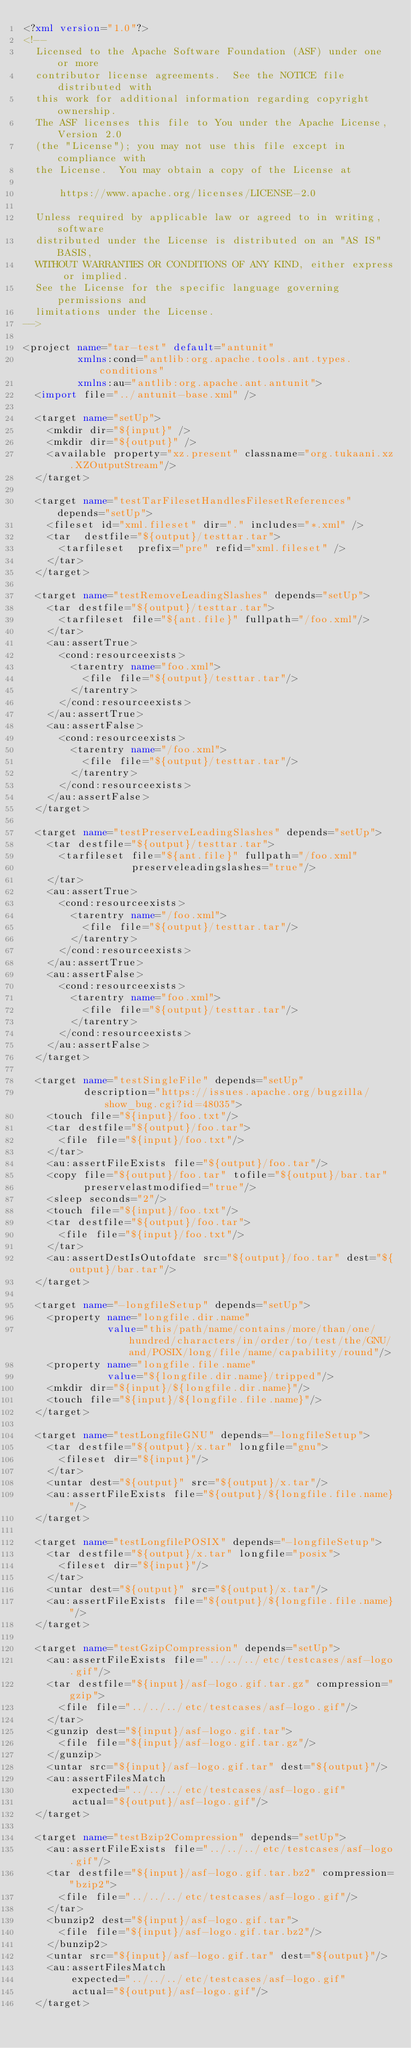Convert code to text. <code><loc_0><loc_0><loc_500><loc_500><_XML_><?xml version="1.0"?>
<!--
  Licensed to the Apache Software Foundation (ASF) under one or more
  contributor license agreements.  See the NOTICE file distributed with
  this work for additional information regarding copyright ownership.
  The ASF licenses this file to You under the Apache License, Version 2.0
  (the "License"); you may not use this file except in compliance with
  the License.  You may obtain a copy of the License at

      https://www.apache.org/licenses/LICENSE-2.0

  Unless required by applicable law or agreed to in writing, software
  distributed under the License is distributed on an "AS IS" BASIS,
  WITHOUT WARRANTIES OR CONDITIONS OF ANY KIND, either express or implied.
  See the License for the specific language governing permissions and
  limitations under the License.
-->

<project name="tar-test" default="antunit"
         xmlns:cond="antlib:org.apache.tools.ant.types.conditions"
         xmlns:au="antlib:org.apache.ant.antunit">
  <import file="../antunit-base.xml" />

  <target name="setUp">
    <mkdir dir="${input}" />
    <mkdir dir="${output}" />
    <available property="xz.present" classname="org.tukaani.xz.XZOutputStream"/>
  </target>

  <target name="testTarFilesetHandlesFilesetReferences" depends="setUp">
    <fileset id="xml.fileset" dir="." includes="*.xml" />
    <tar  destfile="${output}/testtar.tar">
      <tarfileset  prefix="pre" refid="xml.fileset" />
    </tar>
  </target>

  <target name="testRemoveLeadingSlashes" depends="setUp">
    <tar destfile="${output}/testtar.tar">
      <tarfileset file="${ant.file}" fullpath="/foo.xml"/>
    </tar>
    <au:assertTrue>
      <cond:resourceexists>
        <tarentry name="foo.xml">
          <file file="${output}/testtar.tar"/>
        </tarentry>
      </cond:resourceexists>
    </au:assertTrue>
    <au:assertFalse>
      <cond:resourceexists>
        <tarentry name="/foo.xml">
          <file file="${output}/testtar.tar"/>
        </tarentry>
      </cond:resourceexists>
    </au:assertFalse>
  </target>

  <target name="testPreserveLeadingSlashes" depends="setUp">
    <tar destfile="${output}/testtar.tar">
      <tarfileset file="${ant.file}" fullpath="/foo.xml"
                  preserveleadingslashes="true"/>
    </tar>
    <au:assertTrue>
      <cond:resourceexists>
        <tarentry name="/foo.xml">
          <file file="${output}/testtar.tar"/>
        </tarentry>
      </cond:resourceexists>
    </au:assertTrue>
    <au:assertFalse>
      <cond:resourceexists>
        <tarentry name="foo.xml">
          <file file="${output}/testtar.tar"/>
        </tarentry>
      </cond:resourceexists>
    </au:assertFalse>
  </target>

  <target name="testSingleFile" depends="setUp"
          description="https://issues.apache.org/bugzilla/show_bug.cgi?id=48035">
    <touch file="${input}/foo.txt"/>
    <tar destfile="${output}/foo.tar">
      <file file="${input}/foo.txt"/>
    </tar>
    <au:assertFileExists file="${output}/foo.tar"/>
    <copy file="${output}/foo.tar" tofile="${output}/bar.tar"
          preservelastmodified="true"/>
    <sleep seconds="2"/>
    <touch file="${input}/foo.txt"/>
    <tar destfile="${output}/foo.tar">
      <file file="${input}/foo.txt"/>
    </tar>
    <au:assertDestIsOutofdate src="${output}/foo.tar" dest="${output}/bar.tar"/>
  </target>

  <target name="-longfileSetup" depends="setUp">
    <property name="longfile.dir.name"
              value="this/path/name/contains/more/than/one/hundred/characters/in/order/to/test/the/GNU/and/POSIX/long/file/name/capability/round"/>
    <property name="longfile.file.name"
              value="${longfile.dir.name}/tripped"/>
    <mkdir dir="${input}/${longfile.dir.name}"/>
    <touch file="${input}/${longfile.file.name}"/>
  </target>

  <target name="testLongfileGNU" depends="-longfileSetup">
    <tar destfile="${output}/x.tar" longfile="gnu">
      <fileset dir="${input}"/>
    </tar>
    <untar dest="${output}" src="${output}/x.tar"/>
    <au:assertFileExists file="${output}/${longfile.file.name}"/>
  </target>

  <target name="testLongfilePOSIX" depends="-longfileSetup">
    <tar destfile="${output}/x.tar" longfile="posix">
      <fileset dir="${input}"/>
    </tar>
    <untar dest="${output}" src="${output}/x.tar"/>
    <au:assertFileExists file="${output}/${longfile.file.name}"/>
  </target>

  <target name="testGzipCompression" depends="setUp">
    <au:assertFileExists file="../../../etc/testcases/asf-logo.gif"/>
    <tar destfile="${input}/asf-logo.gif.tar.gz" compression="gzip">
      <file file="../../../etc/testcases/asf-logo.gif"/>
    </tar>
    <gunzip dest="${input}/asf-logo.gif.tar">
      <file file="${input}/asf-logo.gif.tar.gz"/>
    </gunzip>
    <untar src="${input}/asf-logo.gif.tar" dest="${output}"/>
    <au:assertFilesMatch
        expected="../../../etc/testcases/asf-logo.gif"
        actual="${output}/asf-logo.gif"/>
  </target>

  <target name="testBzip2Compression" depends="setUp">
    <au:assertFileExists file="../../../etc/testcases/asf-logo.gif"/>
    <tar destfile="${input}/asf-logo.gif.tar.bz2" compression="bzip2">
      <file file="../../../etc/testcases/asf-logo.gif"/>
    </tar>
    <bunzip2 dest="${input}/asf-logo.gif.tar">
      <file file="${input}/asf-logo.gif.tar.bz2"/>
    </bunzip2>
    <untar src="${input}/asf-logo.gif.tar" dest="${output}"/>
    <au:assertFilesMatch
        expected="../../../etc/testcases/asf-logo.gif"
        actual="${output}/asf-logo.gif"/>
  </target>
</code> 